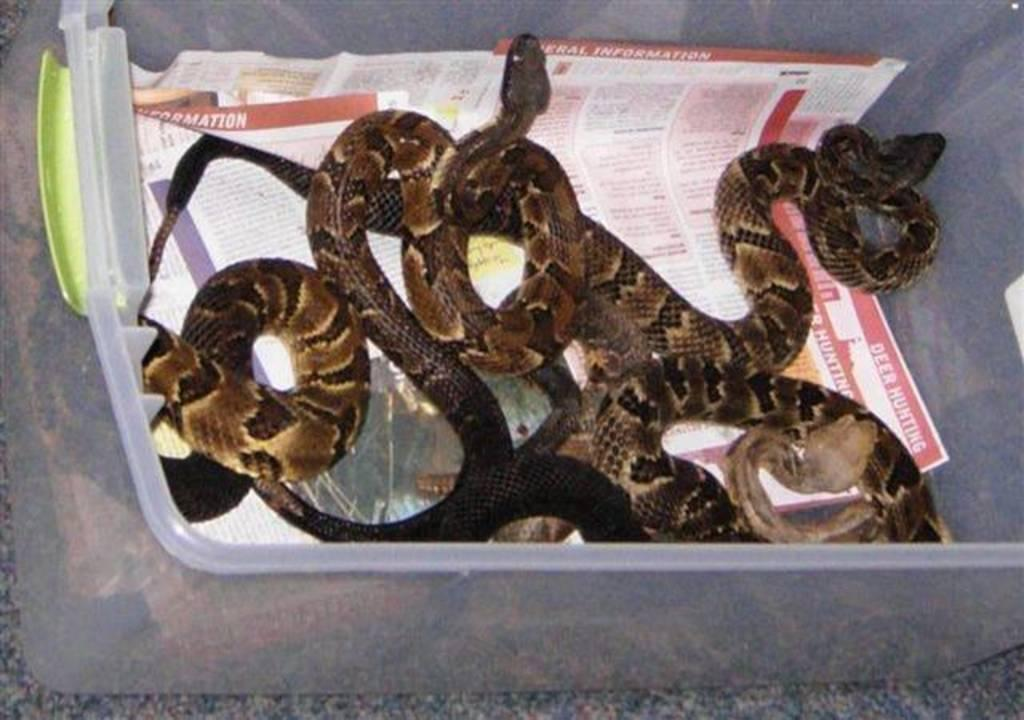What type of animals are present in the image? There are snakes in the image. What other objects can be seen in the image? There are papers in the image. Where are the snakes and papers located? Both snakes and papers are in a box. What impulse might the snakes have in the image? There is no indication of any impulses or actions of the snakes in the image; they are simply present in the box with the papers. How many girls are visible in the image? There are no girls present in the image. What role does the minister play in the image? There is no minister present in the image. 